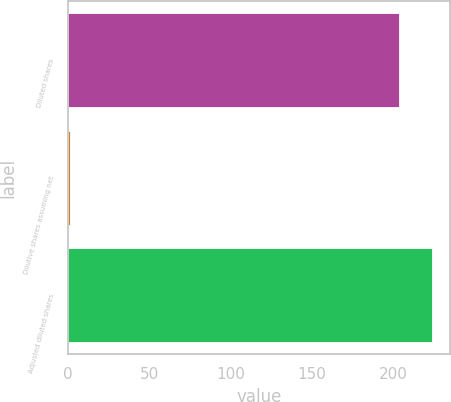Convert chart to OTSL. <chart><loc_0><loc_0><loc_500><loc_500><bar_chart><fcel>Diluted shares<fcel>Dilutive shares assuming net<fcel>Adjusted diluted shares<nl><fcel>203.5<fcel>1.5<fcel>223.85<nl></chart> 